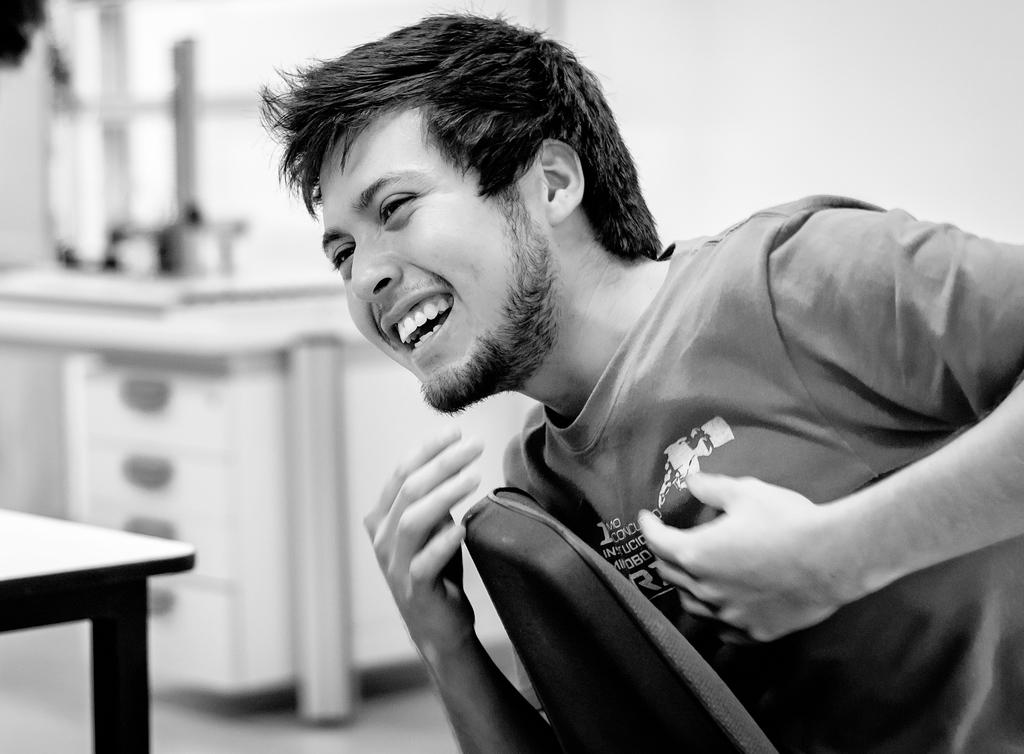What is the man in the image doing? The man is seated in the image. What is the man's facial expression? The man is smiling. What piece of furniture is the man sitting on? There is a chair in the image. What can be seen on the left side of the image? There is a table on the left side of the image. What can be seen on the right side of the image? There is a table with drawers on the right side of the image. What type of pump can be seen in the image? There is no pump present in the image. Can you tell me how many goats are in the shop in the image? There is no shop or goats present in the image. 